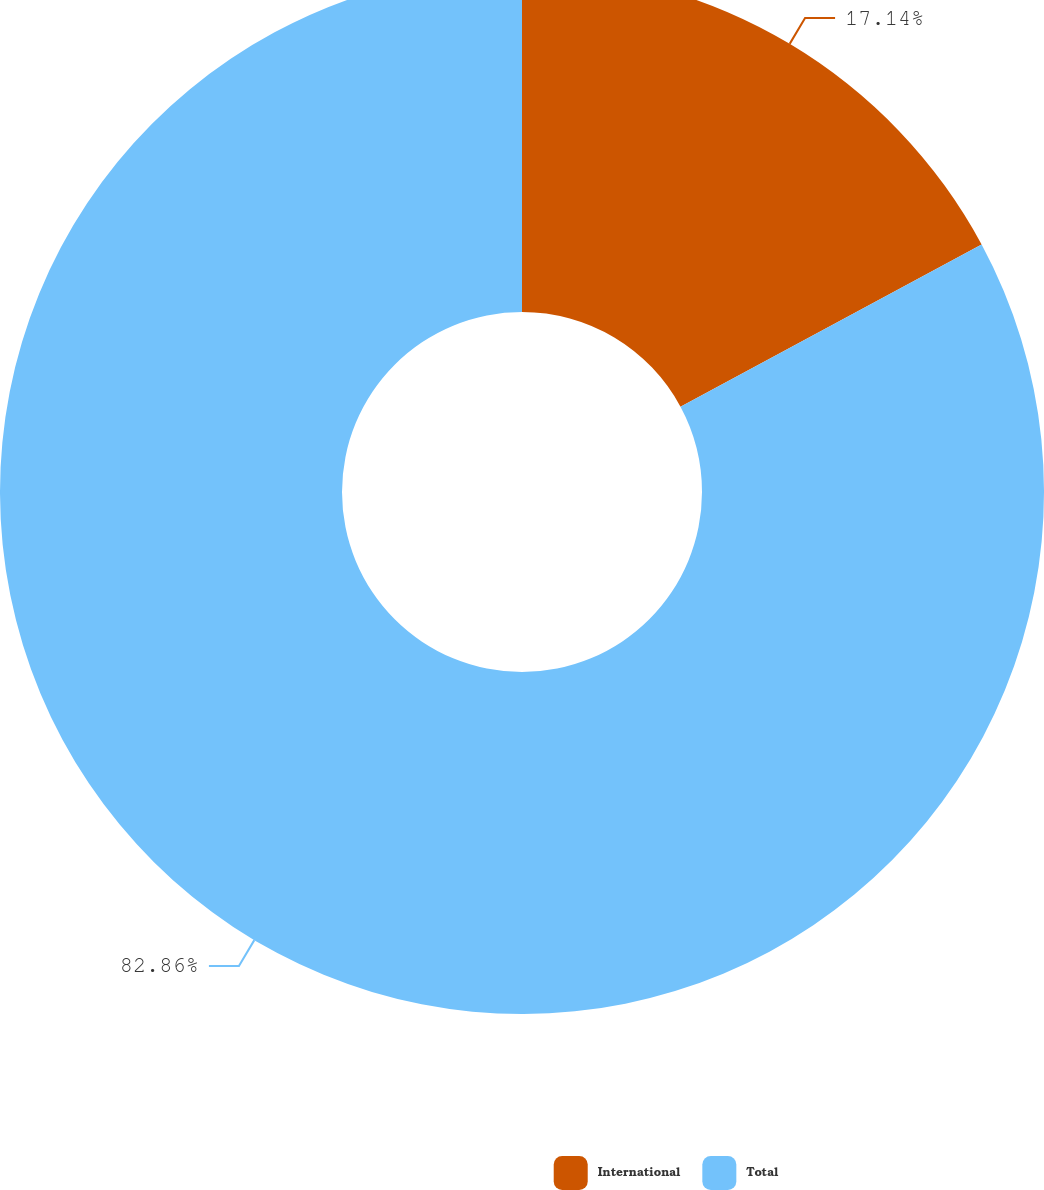<chart> <loc_0><loc_0><loc_500><loc_500><pie_chart><fcel>International<fcel>Total<nl><fcel>17.14%<fcel>82.86%<nl></chart> 